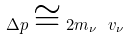<formula> <loc_0><loc_0><loc_500><loc_500>\Delta p \cong 2 m _ { \nu } \ v _ { \nu }</formula> 